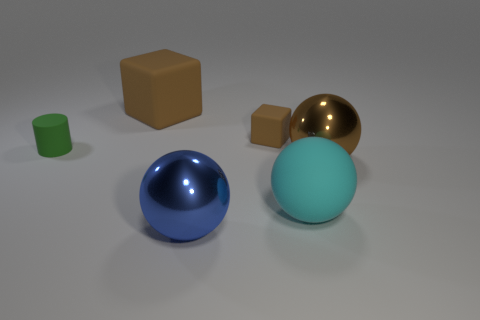What is the shape of the big object that is behind the metal object behind the large cyan object? cube 